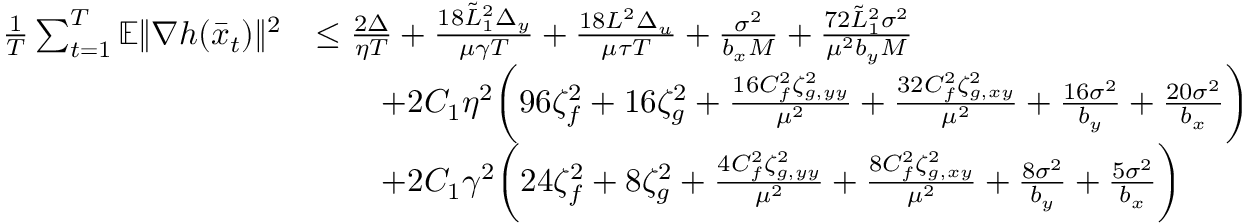Convert formula to latex. <formula><loc_0><loc_0><loc_500><loc_500>\begin{array} { r l } { \frac { 1 } { T } \sum _ { t = 1 } ^ { T } \mathbb { E } \| \nabla h ( \bar { x } _ { t } ) \| ^ { 2 } } & { \leq \frac { 2 \Delta } { \eta T } + \frac { 1 8 \tilde { L } _ { 1 } ^ { 2 } \Delta _ { y } } { \mu \gamma T } + \frac { 1 8 L ^ { 2 } \Delta _ { u } } { \mu \tau T } + \frac { \sigma ^ { 2 } } { b _ { x } M } + \frac { 7 2 \tilde { L } _ { 1 } ^ { 2 } \sigma ^ { 2 } } { \mu ^ { 2 } b _ { y } M } } \\ & { \quad + 2 C _ { 1 } \eta ^ { 2 } \left ( 9 6 \zeta _ { f } ^ { 2 } + 1 6 \zeta _ { g } ^ { 2 } + \frac { 1 6 C _ { f } ^ { 2 } \zeta _ { g , y y } ^ { 2 } } { \mu ^ { 2 } } + \frac { 3 2 C _ { f } ^ { 2 } \zeta _ { g , x y } ^ { 2 } } { \mu ^ { 2 } } + \frac { 1 6 \sigma ^ { 2 } } { b _ { y } } + \frac { 2 0 \sigma ^ { 2 } } { b _ { x } } \right ) } \\ & { \quad + 2 C _ { 1 } \gamma ^ { 2 } \left ( 2 4 \zeta _ { f } ^ { 2 } + 8 \zeta _ { g } ^ { 2 } + \frac { 4 C _ { f } ^ { 2 } \zeta _ { g , y y } ^ { 2 } } { \mu ^ { 2 } } + \frac { 8 C _ { f } ^ { 2 } \zeta _ { g , x y } ^ { 2 } } { \mu ^ { 2 } } + \frac { 8 \sigma ^ { 2 } } { b _ { y } } + \frac { 5 \sigma ^ { 2 } } { b _ { x } } \right ) } \end{array}</formula> 